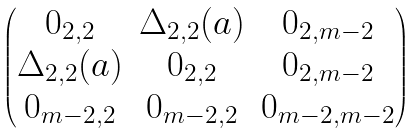<formula> <loc_0><loc_0><loc_500><loc_500>\begin{pmatrix} 0 _ { 2 , 2 } & \Delta _ { 2 , 2 } ( a ) & 0 _ { 2 , m - 2 } \\ \Delta _ { 2 , 2 } ( a ) & 0 _ { 2 , 2 } & 0 _ { 2 , m - 2 } \\ 0 _ { m - 2 , 2 } & 0 _ { m - 2 , 2 } & 0 _ { m - 2 , m - 2 } \end{pmatrix}</formula> 